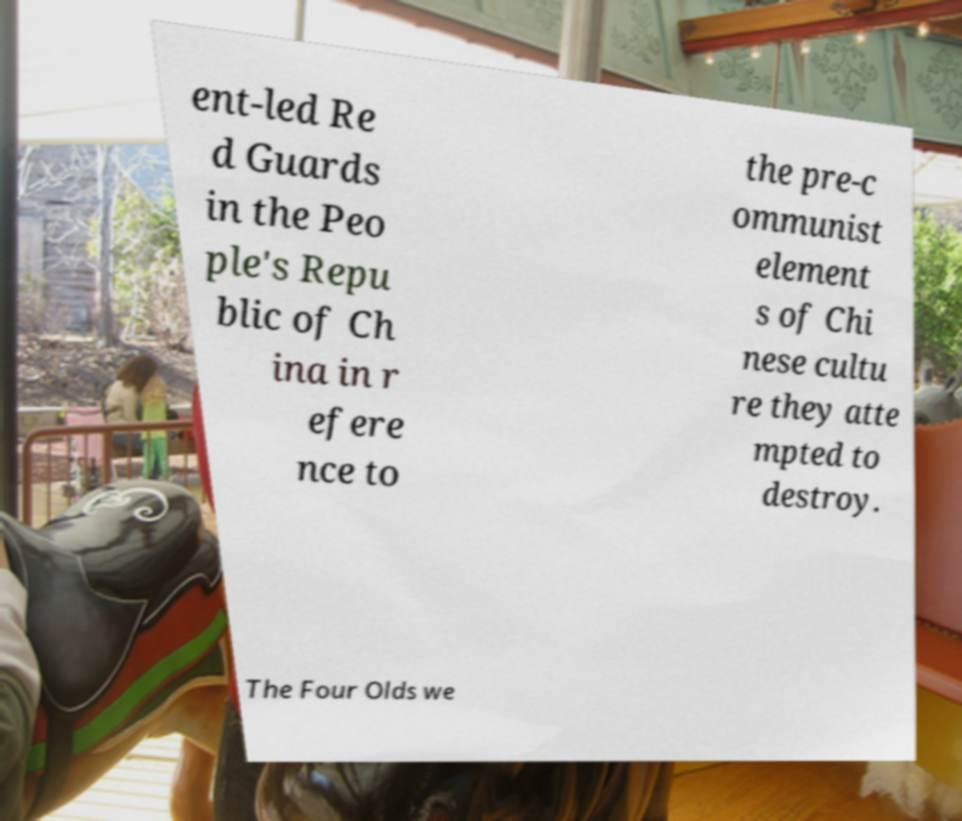There's text embedded in this image that I need extracted. Can you transcribe it verbatim? ent-led Re d Guards in the Peo ple's Repu blic of Ch ina in r efere nce to the pre-c ommunist element s of Chi nese cultu re they atte mpted to destroy. The Four Olds we 